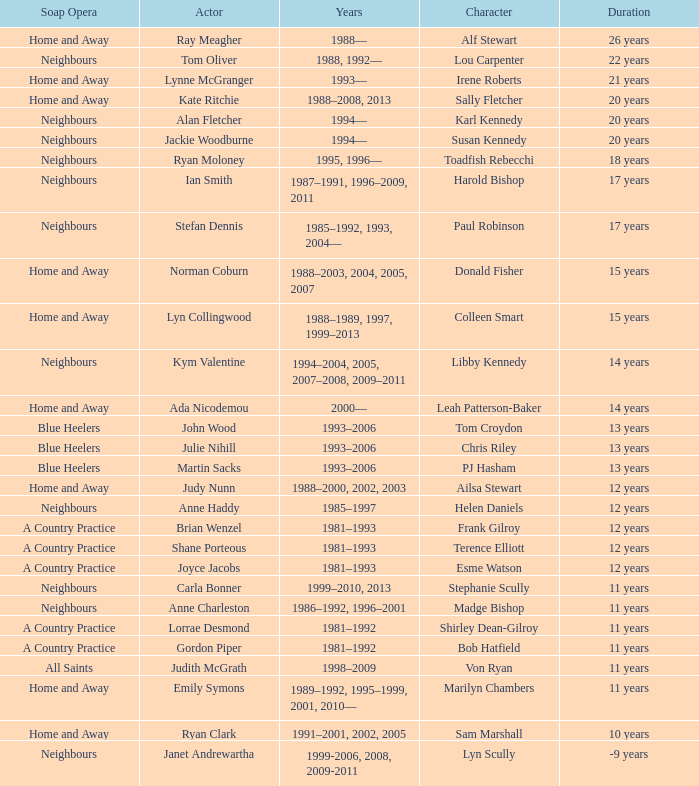What character was portrayed by the same actor for 12 years on Neighbours? Helen Daniels. 